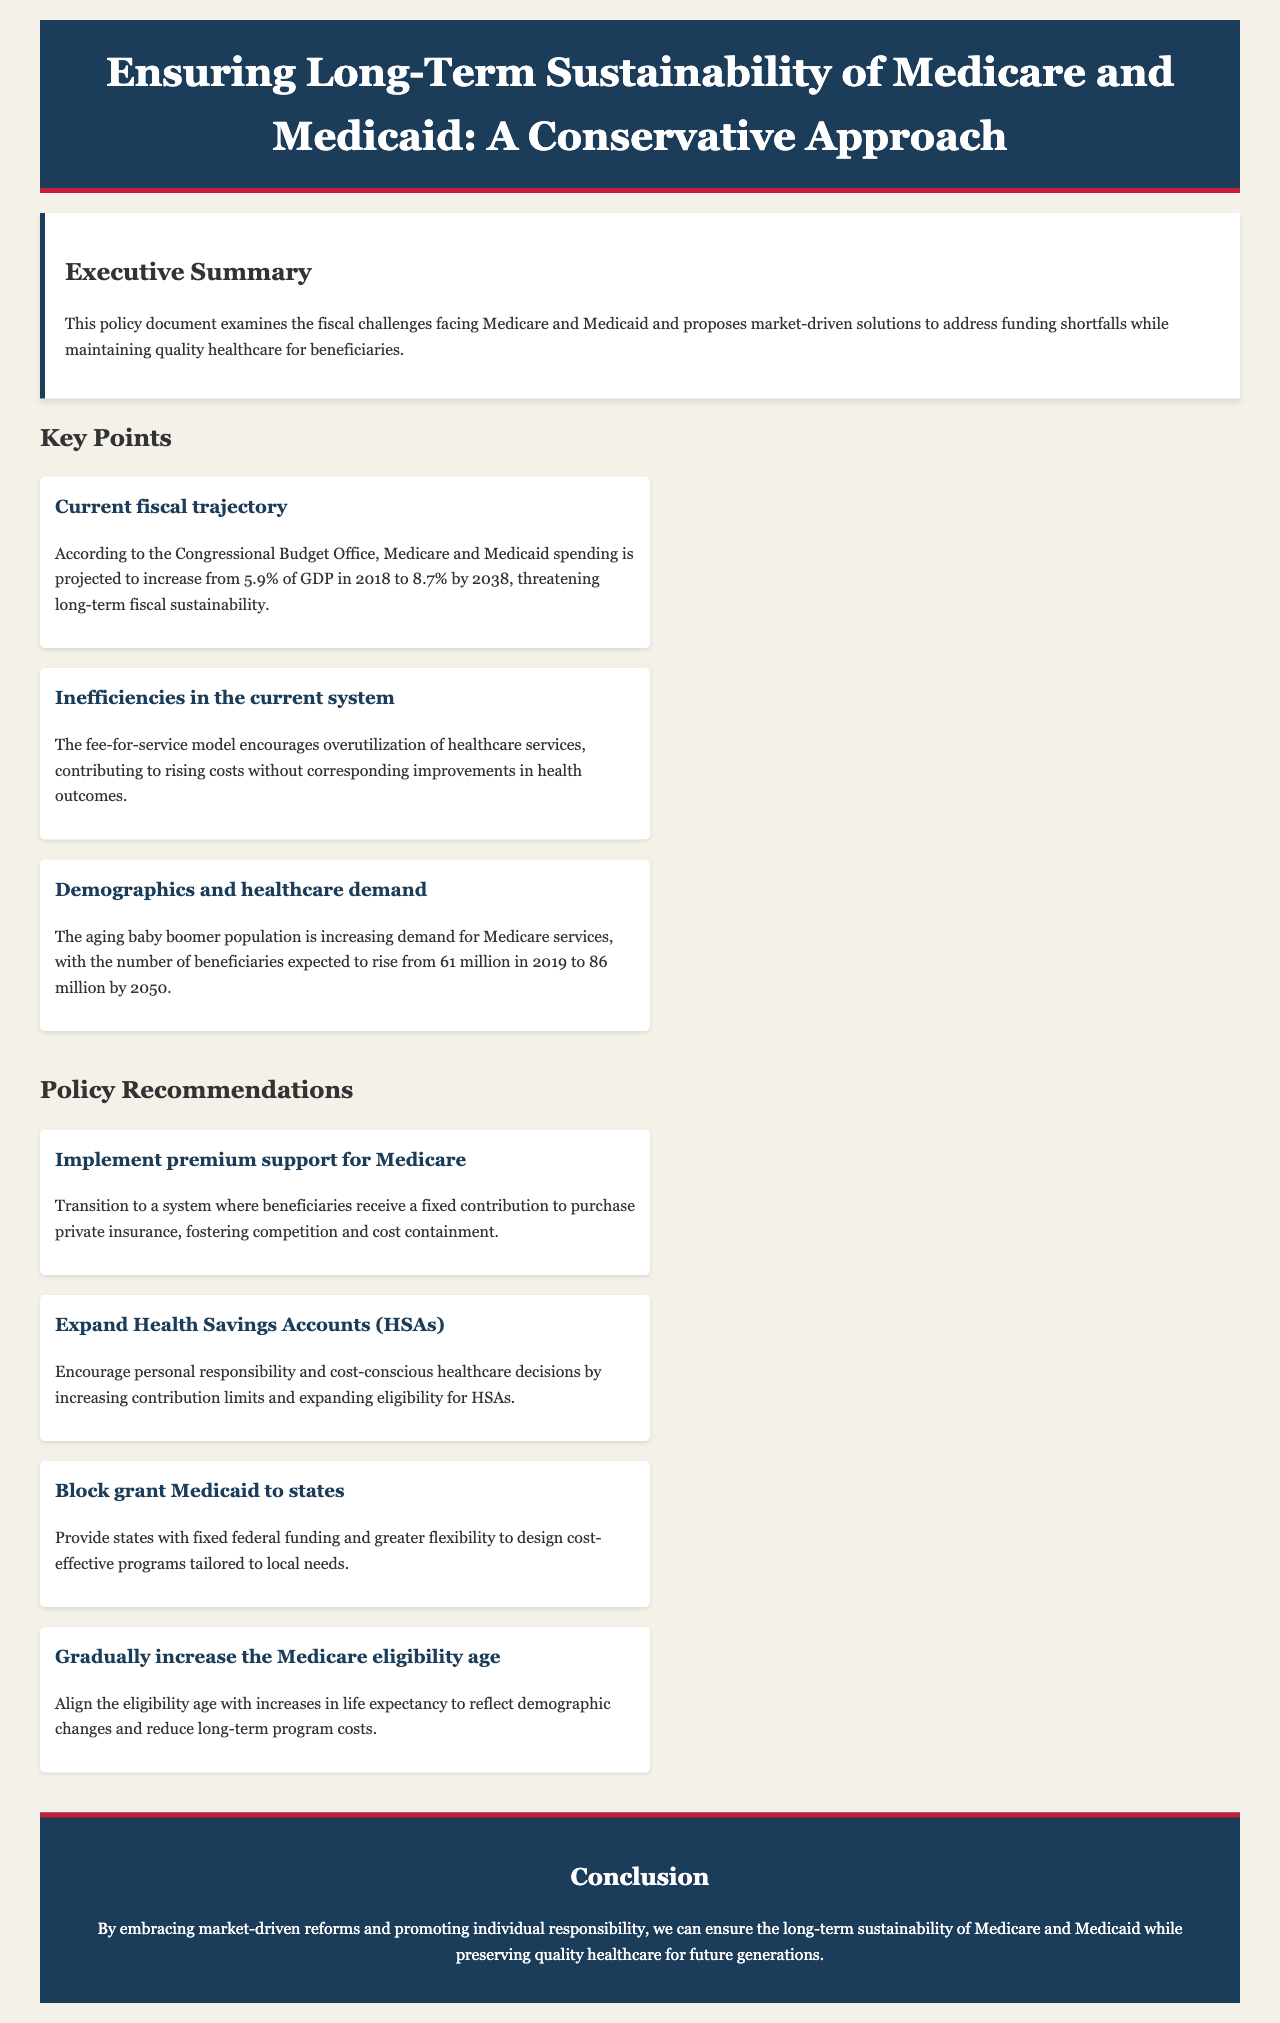What is the projected increase in Medicare and Medicaid spending by 2038? The document states that Medicare and Medicaid spending is projected to increase to 8.7% of GDP by 2038.
Answer: 8.7% How many beneficiaries are expected in Medicare by 2050? According to the document, the number of beneficiaries is expected to rise to 86 million by 2050.
Answer: 86 million What model encourages overutilization of healthcare services? The document mentions that the fee-for-service model encourages overutilization of healthcare services.
Answer: fee-for-service model What is one proposed policy for Medicare? The document recommends implementing premium support for Medicare.
Answer: premium support What change does the document suggest regarding the Medicare eligibility age? The document suggests gradually increasing the Medicare eligibility age.
Answer: gradually increase What demographic factor is increasing demand for Medicare services? The document indicates that the aging baby boomer population is increasing demand for Medicare services.
Answer: aging baby boomer population How does the document classify its approach to reforms? The document describes its approach as market-driven reforms that promote individual responsibility.
Answer: market-driven reforms What is one way proposed to provide states with Medicaid funding? The document proposes block granting Medicaid to states.
Answer: block granting 